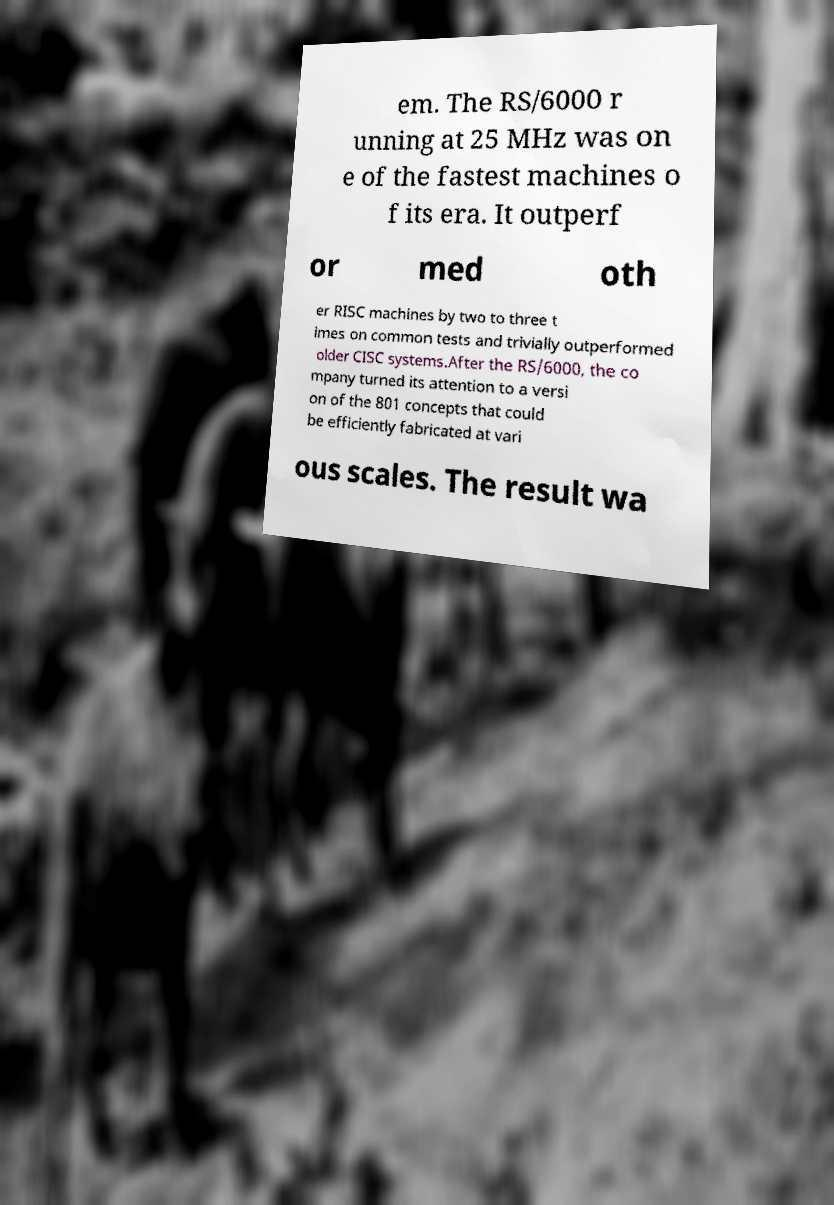What messages or text are displayed in this image? I need them in a readable, typed format. em. The RS/6000 r unning at 25 MHz was on e of the fastest machines o f its era. It outperf or med oth er RISC machines by two to three t imes on common tests and trivially outperformed older CISC systems.After the RS/6000, the co mpany turned its attention to a versi on of the 801 concepts that could be efficiently fabricated at vari ous scales. The result wa 